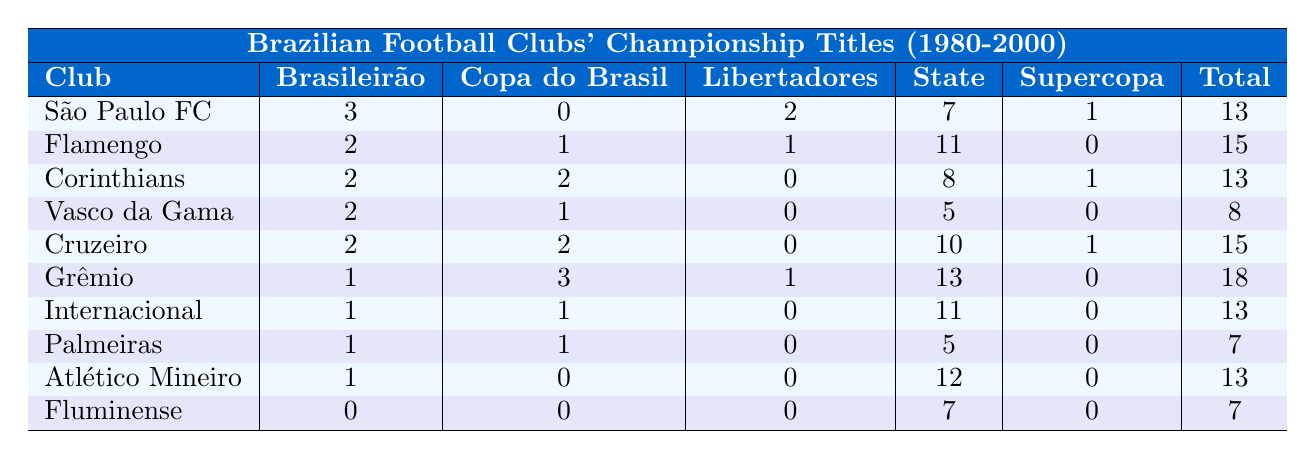What club has the most total titles from 1980 to 2000? By looking at the "Total" column in the table, we see Grêmio has the highest total of 18 titles.
Answer: Grêmio How many titles did Flamengo win in the Campeonato Brasileiro? The "Brasileirão" column shows that Flamengo won 2 titles.
Answer: 2 Which club has no Copa do Brasil titles? By scanning the "Copa do Brasil" column, we see that São Paulo FC has 0 titles.
Answer: São Paulo FC What is the total number of titles won by Corinthians? To find the total, we add up all their titles: 2 (Brasileirão) + 2 (Copa do Brasil) + 0 (Libertadores) + 8 (Paulista) + 1 (Supercopa) = 13.
Answer: 13 Did Fluminense win any Libertadores titles? Checking the "Libertadores" column, Fluminense has 0 titles.
Answer: No Which club has more state titles: Atlético Mineiro or Palmeiras? Atlético Mineiro has 12 titles (Mineiro) while Palmeiras has 5 titles (Paulista). Thus, Atlético Mineiro has more state titles.
Answer: Atlético Mineiro How many clubs won the Libertadores at least once between 1980 and 2000? São Paulo FC, Flamengo, Grêmio have won the Libertadores, which gives us a total of 3 clubs.
Answer: 3 What is the average number of Brasileirão titles among the clubs listed? We total the Brasileirão titles: 3 + 2 + 2 + 2 + 2 + 1 + 1 + 1 + 1 + 0 = 15. Dividing by 10 clubs gives us an average of 15/10 = 1.5.
Answer: 1.5 Which club has the most Carioca titles? The "carioca" column indicates Flamengo has the most with 11 titles.
Answer: Flamengo Is it true that only São Paulo FC and Grêmio have won the Supercopa? The Supercopa column has São Paulo FC and Grêmio both with titles (1 each), while others have 0. Thus, only these two clubs have won it.
Answer: Yes 